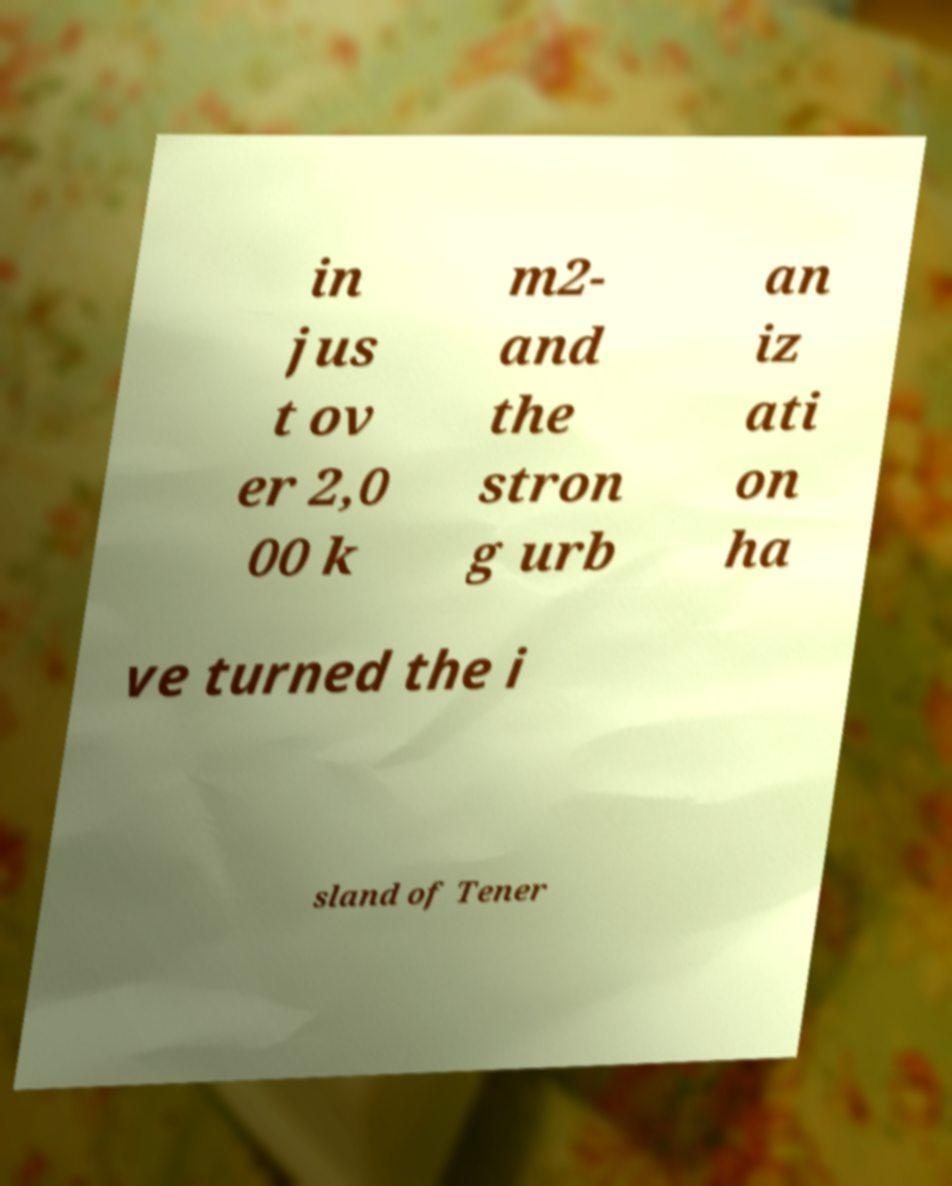There's text embedded in this image that I need extracted. Can you transcribe it verbatim? in jus t ov er 2,0 00 k m2- and the stron g urb an iz ati on ha ve turned the i sland of Tener 